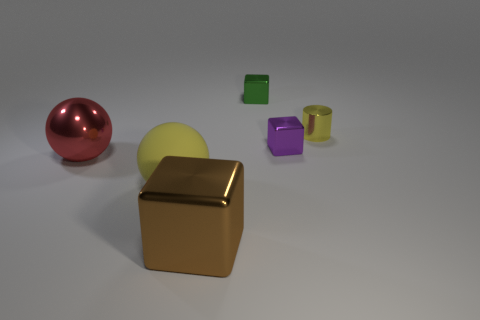Subtract all tiny shiny blocks. How many blocks are left? 1 Subtract all green blocks. How many blocks are left? 2 Add 4 tiny metallic cylinders. How many objects exist? 10 Subtract all balls. How many objects are left? 4 Subtract all red blocks. Subtract all purple cylinders. How many blocks are left? 3 Subtract all gray cylinders. How many red spheres are left? 1 Subtract all yellow rubber things. Subtract all purple cubes. How many objects are left? 4 Add 6 tiny things. How many tiny things are left? 9 Add 1 purple blocks. How many purple blocks exist? 2 Subtract 1 red spheres. How many objects are left? 5 